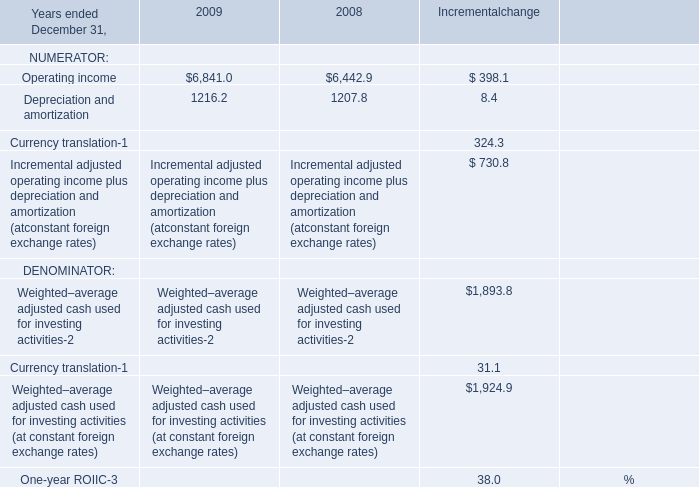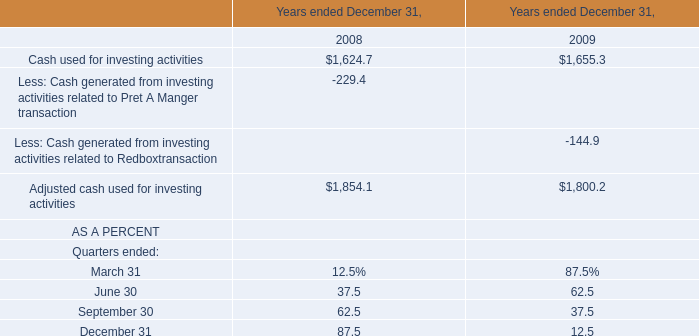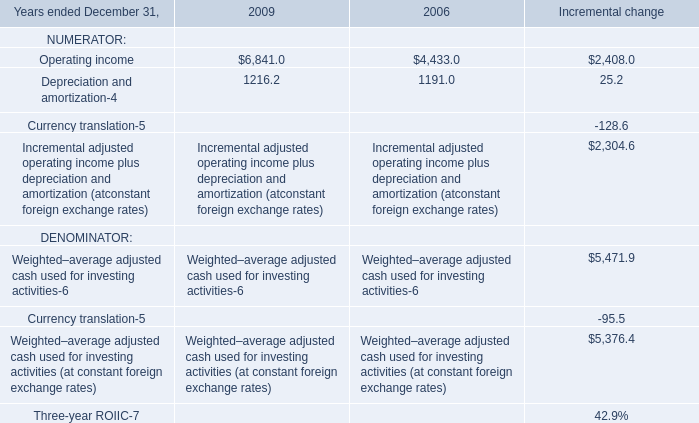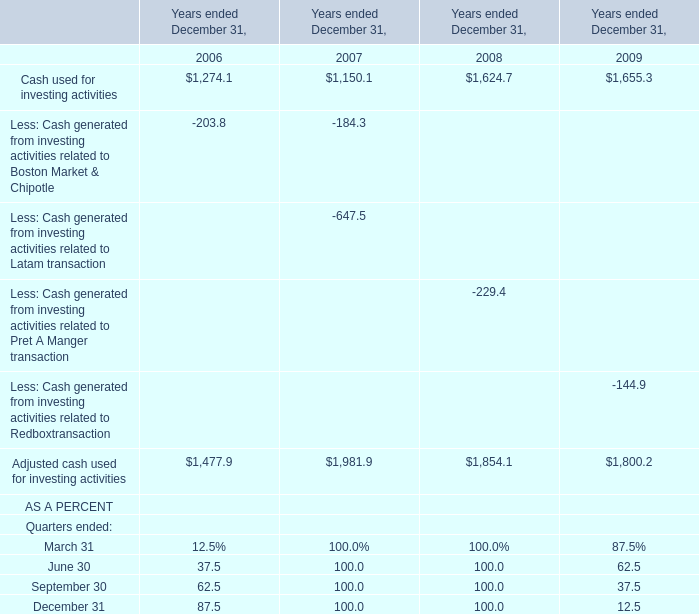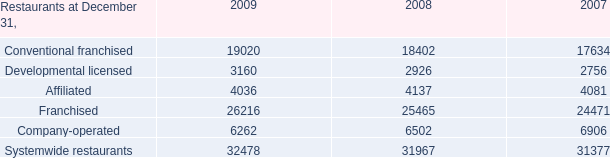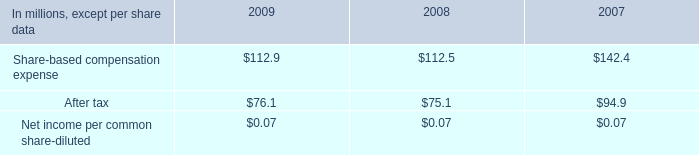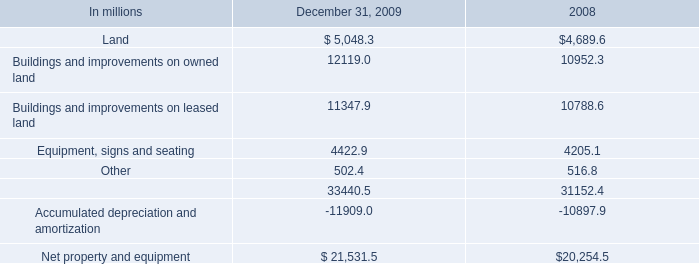How many Quarters continues to decrease each year from 2007 to 2009 in terms of AS A PERCENT? 
Answer: 0. 